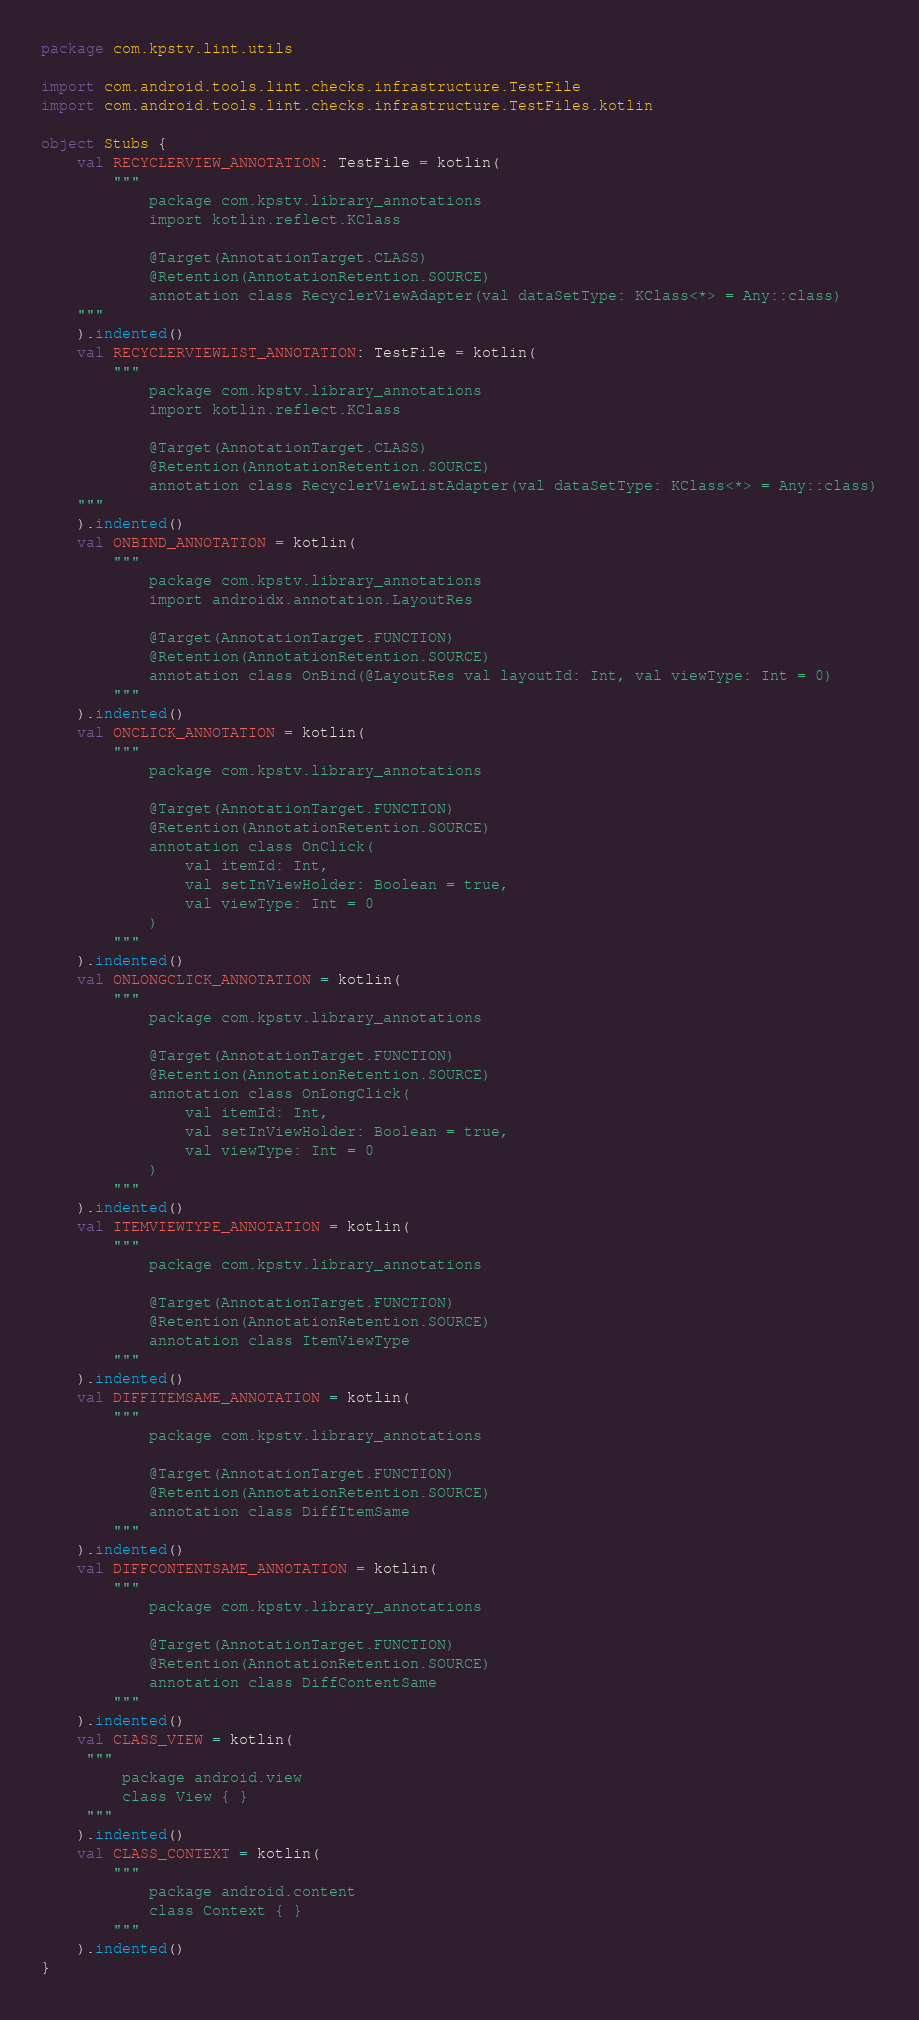<code> <loc_0><loc_0><loc_500><loc_500><_Kotlin_>package com.kpstv.lint.utils

import com.android.tools.lint.checks.infrastructure.TestFile
import com.android.tools.lint.checks.infrastructure.TestFiles.kotlin

object Stubs {
    val RECYCLERVIEW_ANNOTATION: TestFile = kotlin(
        """
            package com.kpstv.library_annotations
            import kotlin.reflect.KClass
            
            @Target(AnnotationTarget.CLASS)
            @Retention(AnnotationRetention.SOURCE)
            annotation class RecyclerViewAdapter(val dataSetType: KClass<*> = Any::class)
    """
    ).indented()
    val RECYCLERVIEWLIST_ANNOTATION: TestFile = kotlin(
        """
            package com.kpstv.library_annotations
            import kotlin.reflect.KClass
            
            @Target(AnnotationTarget.CLASS)
            @Retention(AnnotationRetention.SOURCE)
            annotation class RecyclerViewListAdapter(val dataSetType: KClass<*> = Any::class)
    """
    ).indented()
    val ONBIND_ANNOTATION = kotlin(
        """
            package com.kpstv.library_annotations
            import androidx.annotation.LayoutRes
            
            @Target(AnnotationTarget.FUNCTION)
            @Retention(AnnotationRetention.SOURCE)
            annotation class OnBind(@LayoutRes val layoutId: Int, val viewType: Int = 0)
        """
    ).indented()
    val ONCLICK_ANNOTATION = kotlin(
        """
            package com.kpstv.library_annotations
            
            @Target(AnnotationTarget.FUNCTION)
            @Retention(AnnotationRetention.SOURCE)
            annotation class OnClick(
                val itemId: Int,
                val setInViewHolder: Boolean = true,
                val viewType: Int = 0
            )
        """
    ).indented()
    val ONLONGCLICK_ANNOTATION = kotlin(
        """
            package com.kpstv.library_annotations
            
            @Target(AnnotationTarget.FUNCTION)
            @Retention(AnnotationRetention.SOURCE)
            annotation class OnLongClick(
                val itemId: Int,
                val setInViewHolder: Boolean = true,
                val viewType: Int = 0
            )
        """
    ).indented()
    val ITEMVIEWTYPE_ANNOTATION = kotlin(
        """
            package com.kpstv.library_annotations
            
            @Target(AnnotationTarget.FUNCTION)
            @Retention(AnnotationRetention.SOURCE)
            annotation class ItemViewType
        """
    ).indented()
    val DIFFITEMSAME_ANNOTATION = kotlin(
        """
            package com.kpstv.library_annotations
            
            @Target(AnnotationTarget.FUNCTION)
            @Retention(AnnotationRetention.SOURCE)
            annotation class DiffItemSame
        """
    ).indented()
    val DIFFCONTENTSAME_ANNOTATION = kotlin(
        """
            package com.kpstv.library_annotations
            
            @Target(AnnotationTarget.FUNCTION)
            @Retention(AnnotationRetention.SOURCE)
            annotation class DiffContentSame
        """
    ).indented()
    val CLASS_VIEW = kotlin(
     """
         package android.view
         class View { }
     """
    ).indented()
    val CLASS_CONTEXT = kotlin(
        """
            package android.content
            class Context { }
        """
    ).indented()
}</code> 